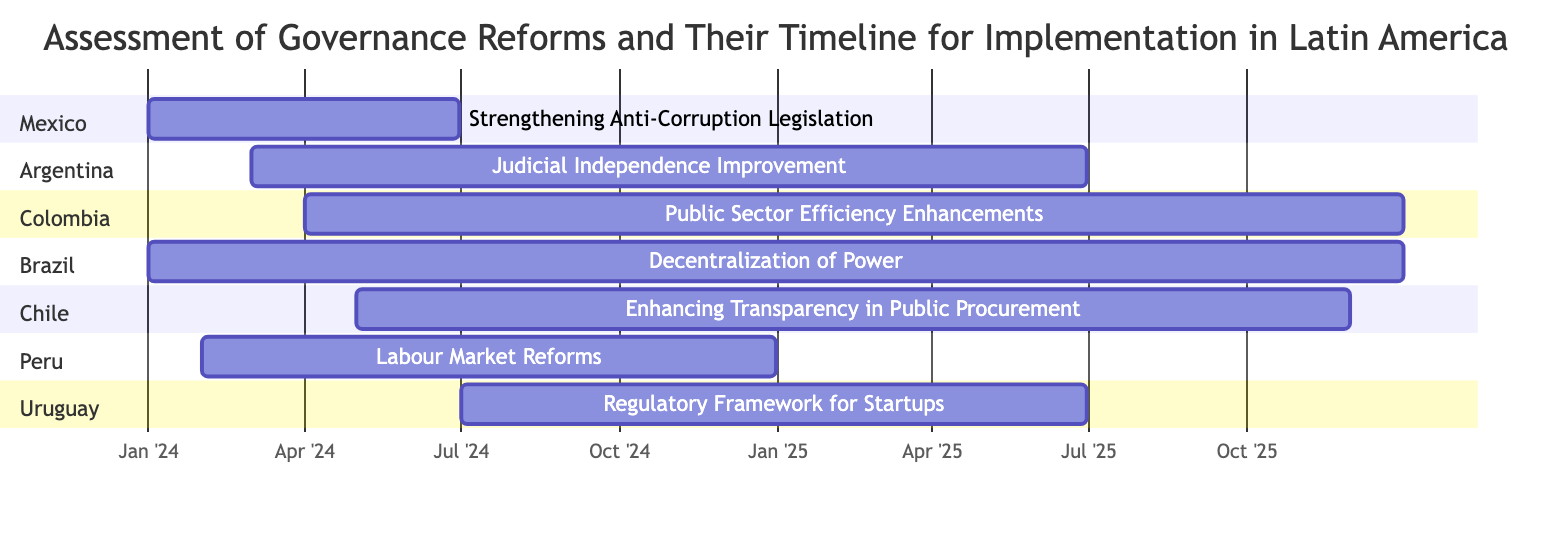What is the duration of the governance reform in Mexico? The governance reform in Mexico, "Strengthening Anti-Corruption Legislation," is scheduled to start on January 1, 2024, and end on June 30, 2024. The duration is calculated as the time from the start date to the end date. Thus, it lasts for exactly six months.
Answer: Six months Which country is implementing "Judicial Independence Improvement"? In the diagram, the reform "Judicial Independence Improvement" is associated with Argentina. By locating the section labeled "Argentina" in the Gantt chart, we identify that this reform is specific to that country.
Answer: Argentina How many governance reforms are expected to be completed by the end of 2024? The diagram lists several governance reforms, and to find out how many are expected to be completed by December 31, 2024, we need to check the end dates. The reforms in Mexico, Peru, and Argentina will conclude by then, totaling three reforms.
Answer: Three What is the latest start date for any governance reform shown in the diagram? The latest start date for the governance reforms is determined by reviewing the start dates of all reforms listed. The reform "Regulatory Framework for Startups" starts on July 1, 2024, which is later than any other reform mentioned.
Answer: July 1, 2024 Which country has the longest scheduled governance reform timeline? To find the longest timeline, we review the duration for each reform listed in the diagram. The reform "Decentralization of Power" in Brazil spans from January 1, 2024, to December 31, 2025, totaling two years. This is the longest duration among the reforms.
Answer: Brazil What are the overlapping months for the reforms in Colombia and Brazil? Both reforms in Colombia ("Public Sector Efficiency Enhancements") and Brazil ("Decentralization of Power") start in 2024 and overlap in several months. By analyzing their timelines, they overlap from April 2024 until December 2025, which shows the extent and duration of their simultaneous implementation.
Answer: April 2024 to December 2025 In which month do the reforms in Chile and Uruguay begin? The reform in Chile, "Enhancing Transparency in Public Procurement," starts in May 2024. The reform in Uruguay, "Regulatory Framework for Startups," begins in July 2024. Thus, both reforms can be identified specifically by checking their designated start months.
Answer: May and July 2024 How many reforms are set to conclude in 2025? By examining the end dates of all listed reforms, we note that the reforms in Argentina, Colombia, Brazil, Chile, and Uruguay all have end dates falling in 2025. Counting these gives us five reforms scheduled to conclude in that year.
Answer: Five 